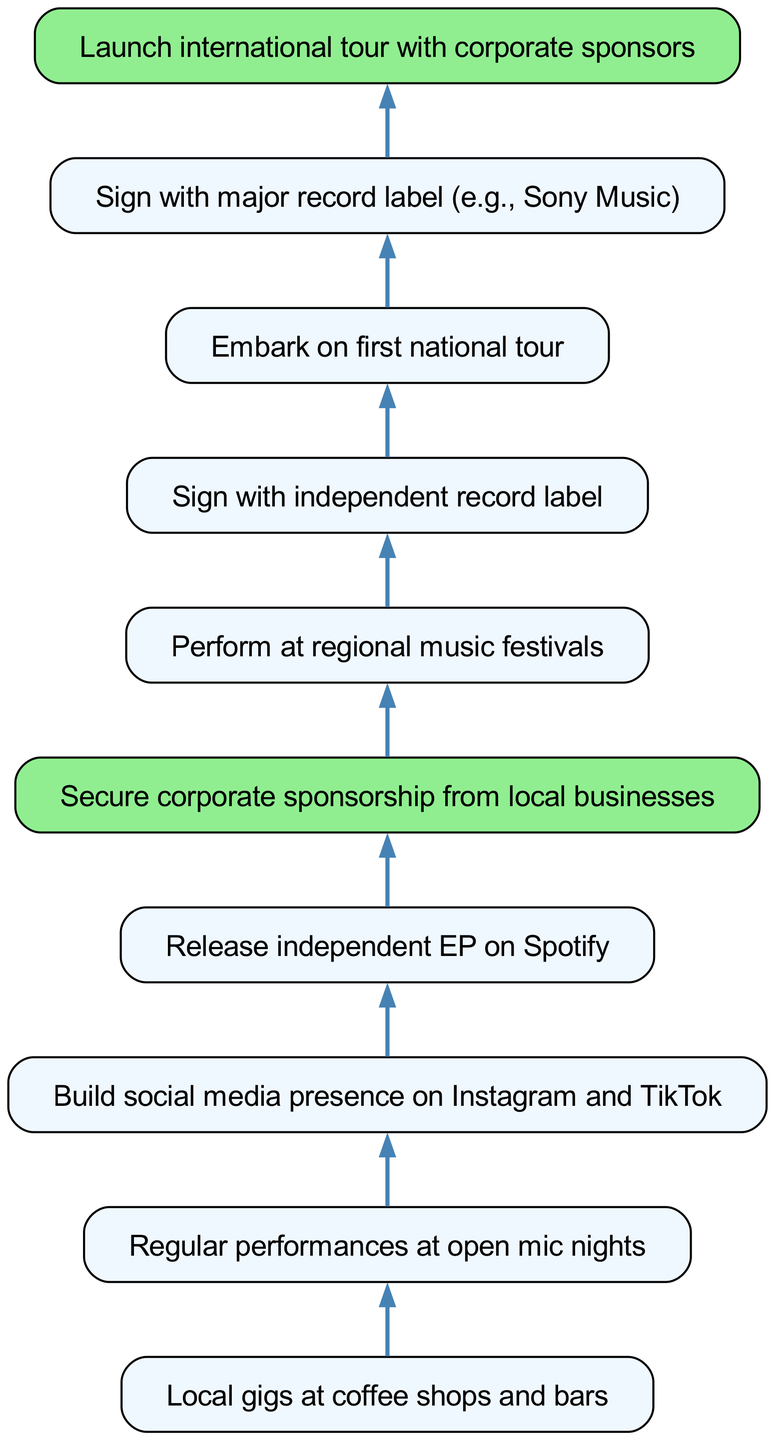What is the starting point of the career growth path? The starting point in the diagram is the node labeled "Local gigs at coffee shops and bars." This is the first node listed at the bottom of the flow chart, indicating where the career begins.
Answer: Local gigs at coffee shops and bars How many nodes are there in the diagram? To find the total number of nodes, we count the elements listed in the "elements" section of the data provided. There are ten distinct career steps included in the career growth path.
Answer: 10 What is the last step before launching an international tour? The last step in the diagram before launching an international tour is the node labeled "Sign with major record label (e.g., Sony Music)." This node directly precedes the "Launch international tour with corporate sponsors" node.
Answer: Sign with major record label (e.g., Sony Music) Which step follows the release of an independent EP? The step that follows the "Release independent EP on Spotify" is "Secure corporate sponsorship from local businesses." This connection is shown as a direct edge leading to the sponsorship node.
Answer: Secure corporate sponsorship from local businesses What type of record label should be signed with after performing at regional festivals? After performing at regional festivals, the diagram indicates that an artist should "Sign with independent record label." This is the immediate next step indicated by the flow chart.
Answer: Sign with independent record label Which two nodes have a direct correlation with corporate sponsorship? The two nodes that have a direct correlation with corporate sponsorship are "Release independent EP on Spotify" and "Perform at regional music festivals." Corporate sponsorship is dependent on these earlier nodes in the career path.
Answer: Release independent EP on Spotify, Perform at regional music festivals What percentage of the nodes lead to a corporate sponsorship step? To find the percentage, we first note that there are two nodes leading to corporate sponsorship (the nodes preceding it: EP release and social media building). Since there are ten nodes total, the percentage is calculated as (2/10) * 100, which equals 20%.
Answer: 20% What is the significance of the highlighted nodes in the diagram? The highlighted nodes ("Secure corporate sponsorship from local businesses" and "Launch international tour with corporate sponsors") indicate crucial points in the career path where corporate sponsors play a key role in advancing the singer-songwriter's career. These nodes may symbolize the importance of financial backing in achieving larger goals in the music industry.
Answer: Corporate sponsors play a key role What is the flow direction of the connections in the diagram? The flow direction in the diagram is from bottom to top, indicating a progression in the career path from local and introductory steps to more significant achievements like signing with major labels and embarking on international tours. Connections are drawn from earlier steps to later ones to showcase this upward movement.
Answer: Bottom to top 